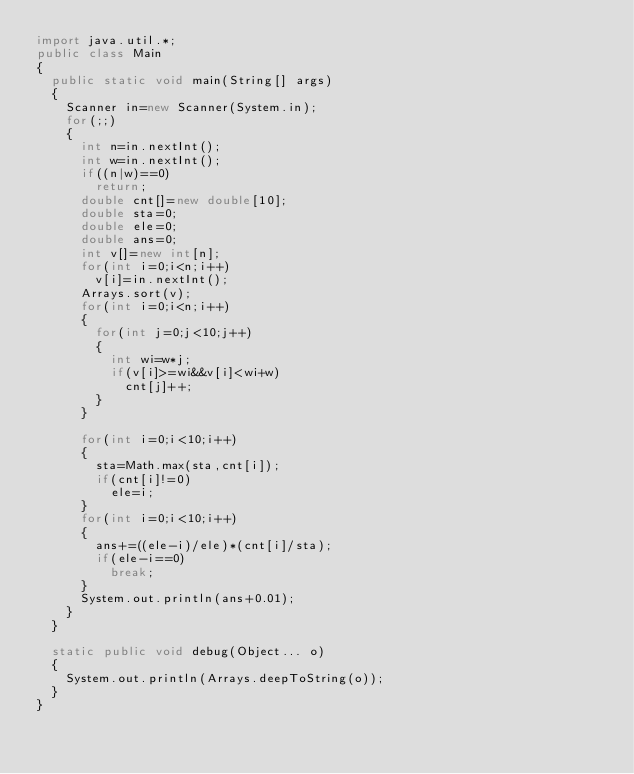Convert code to text. <code><loc_0><loc_0><loc_500><loc_500><_Java_>import java.util.*;
public class Main
{
	public static void main(String[] args) 
	{
		Scanner in=new Scanner(System.in);
		for(;;)
		{
			int n=in.nextInt();
			int w=in.nextInt();
			if((n|w)==0)
				return;
			double cnt[]=new double[10];
			double sta=0;
			double ele=0;
			double ans=0;
			int v[]=new int[n];
			for(int i=0;i<n;i++)
				v[i]=in.nextInt();
			Arrays.sort(v);
			for(int i=0;i<n;i++)
			{
				for(int j=0;j<10;j++)
				{
					int wi=w*j;
					if(v[i]>=wi&&v[i]<wi+w)
						cnt[j]++;
				}
			}
			
			for(int i=0;i<10;i++)
			{
				sta=Math.max(sta,cnt[i]);
				if(cnt[i]!=0)
					ele=i;
			}
			for(int i=0;i<10;i++)
			{
				ans+=((ele-i)/ele)*(cnt[i]/sta);
				if(ele-i==0)
					break;
			}
			System.out.println(ans+0.01);
		}
	}

	static public void debug(Object... o)
	{
		System.out.println(Arrays.deepToString(o));
	}
}</code> 